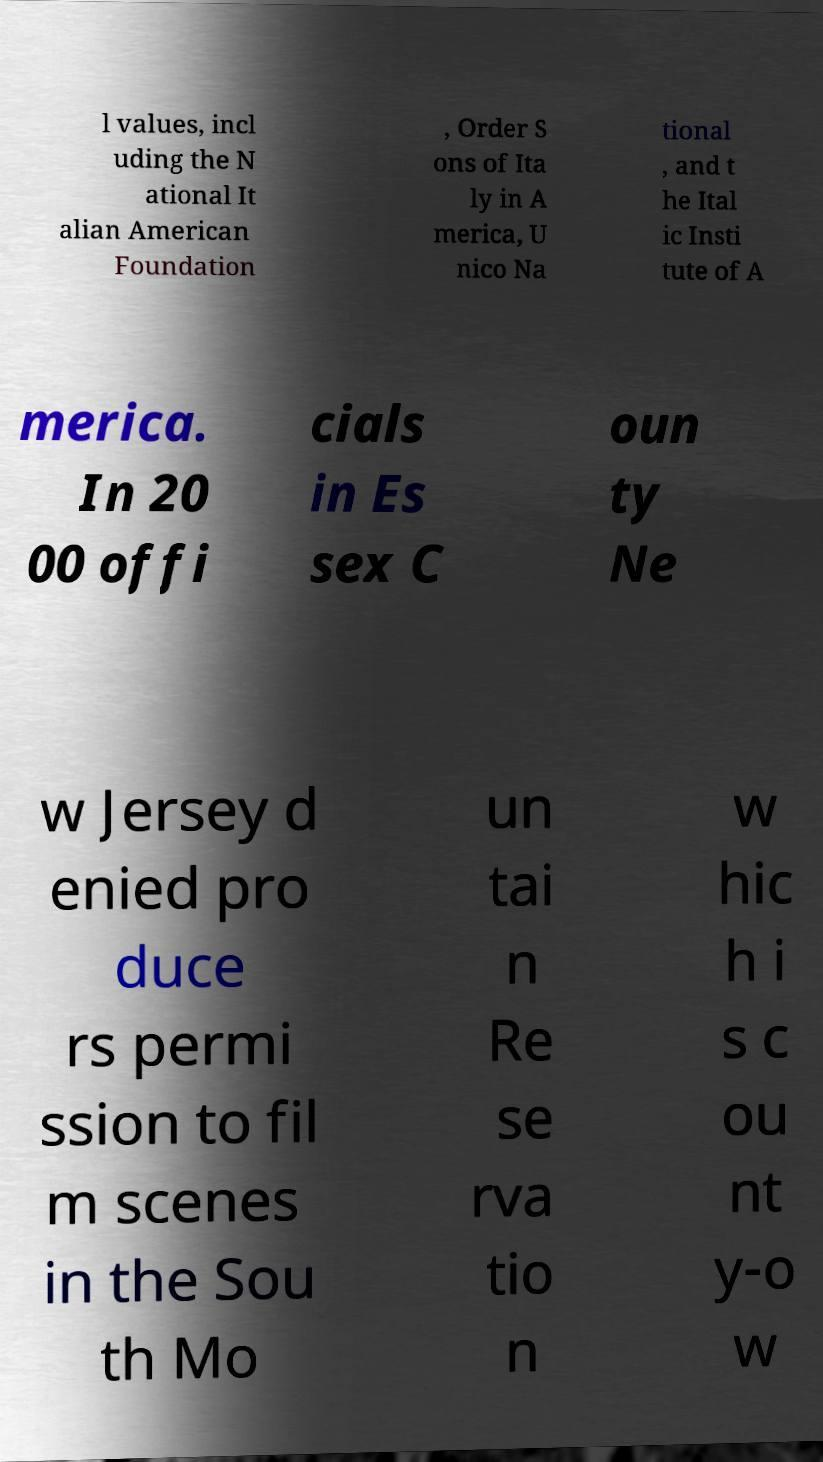Please identify and transcribe the text found in this image. l values, incl uding the N ational It alian American Foundation , Order S ons of Ita ly in A merica, U nico Na tional , and t he Ital ic Insti tute of A merica. In 20 00 offi cials in Es sex C oun ty Ne w Jersey d enied pro duce rs permi ssion to fil m scenes in the Sou th Mo un tai n Re se rva tio n w hic h i s c ou nt y-o w 